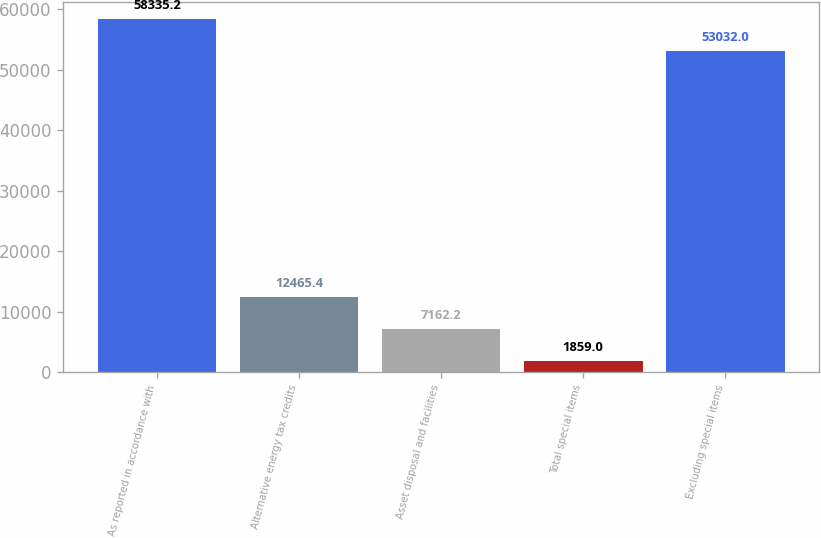Convert chart. <chart><loc_0><loc_0><loc_500><loc_500><bar_chart><fcel>As reported in accordance with<fcel>Alternative energy tax credits<fcel>Asset disposal and facilities<fcel>Total special items<fcel>Excluding special items<nl><fcel>58335.2<fcel>12465.4<fcel>7162.2<fcel>1859<fcel>53032<nl></chart> 